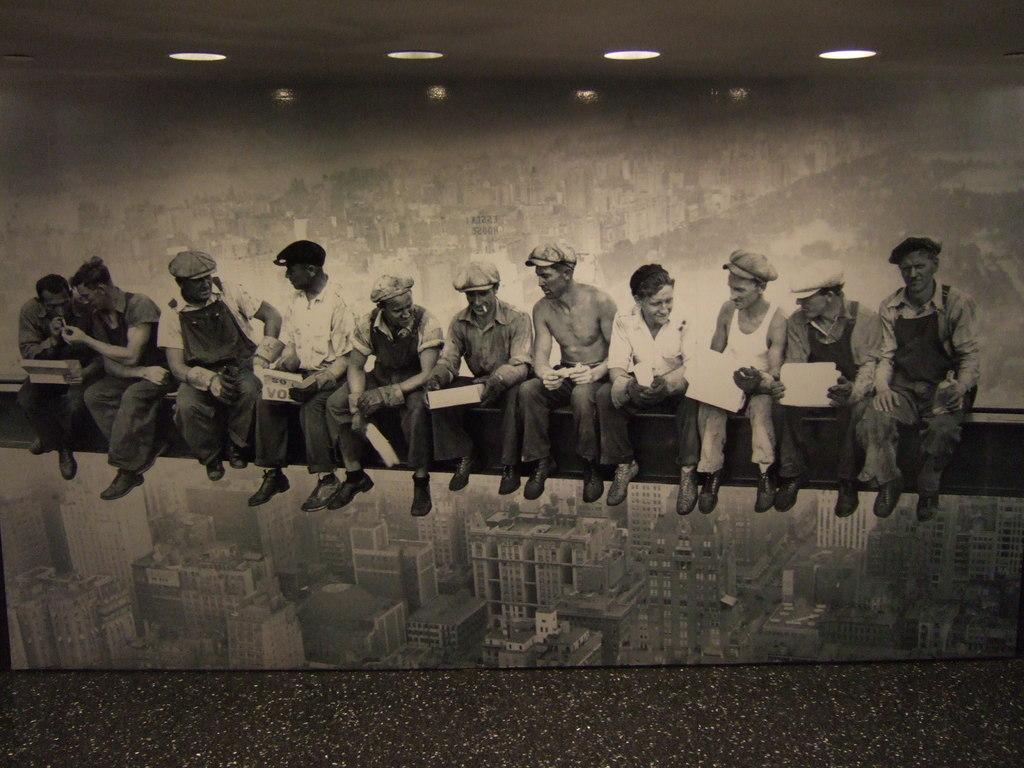How would you summarize this image in a sentence or two? In this black and white image there are a few people sitting on a metal rod, in the background there is a wall with an image of buildings. At the top of the image there is a ceiling with lights. 